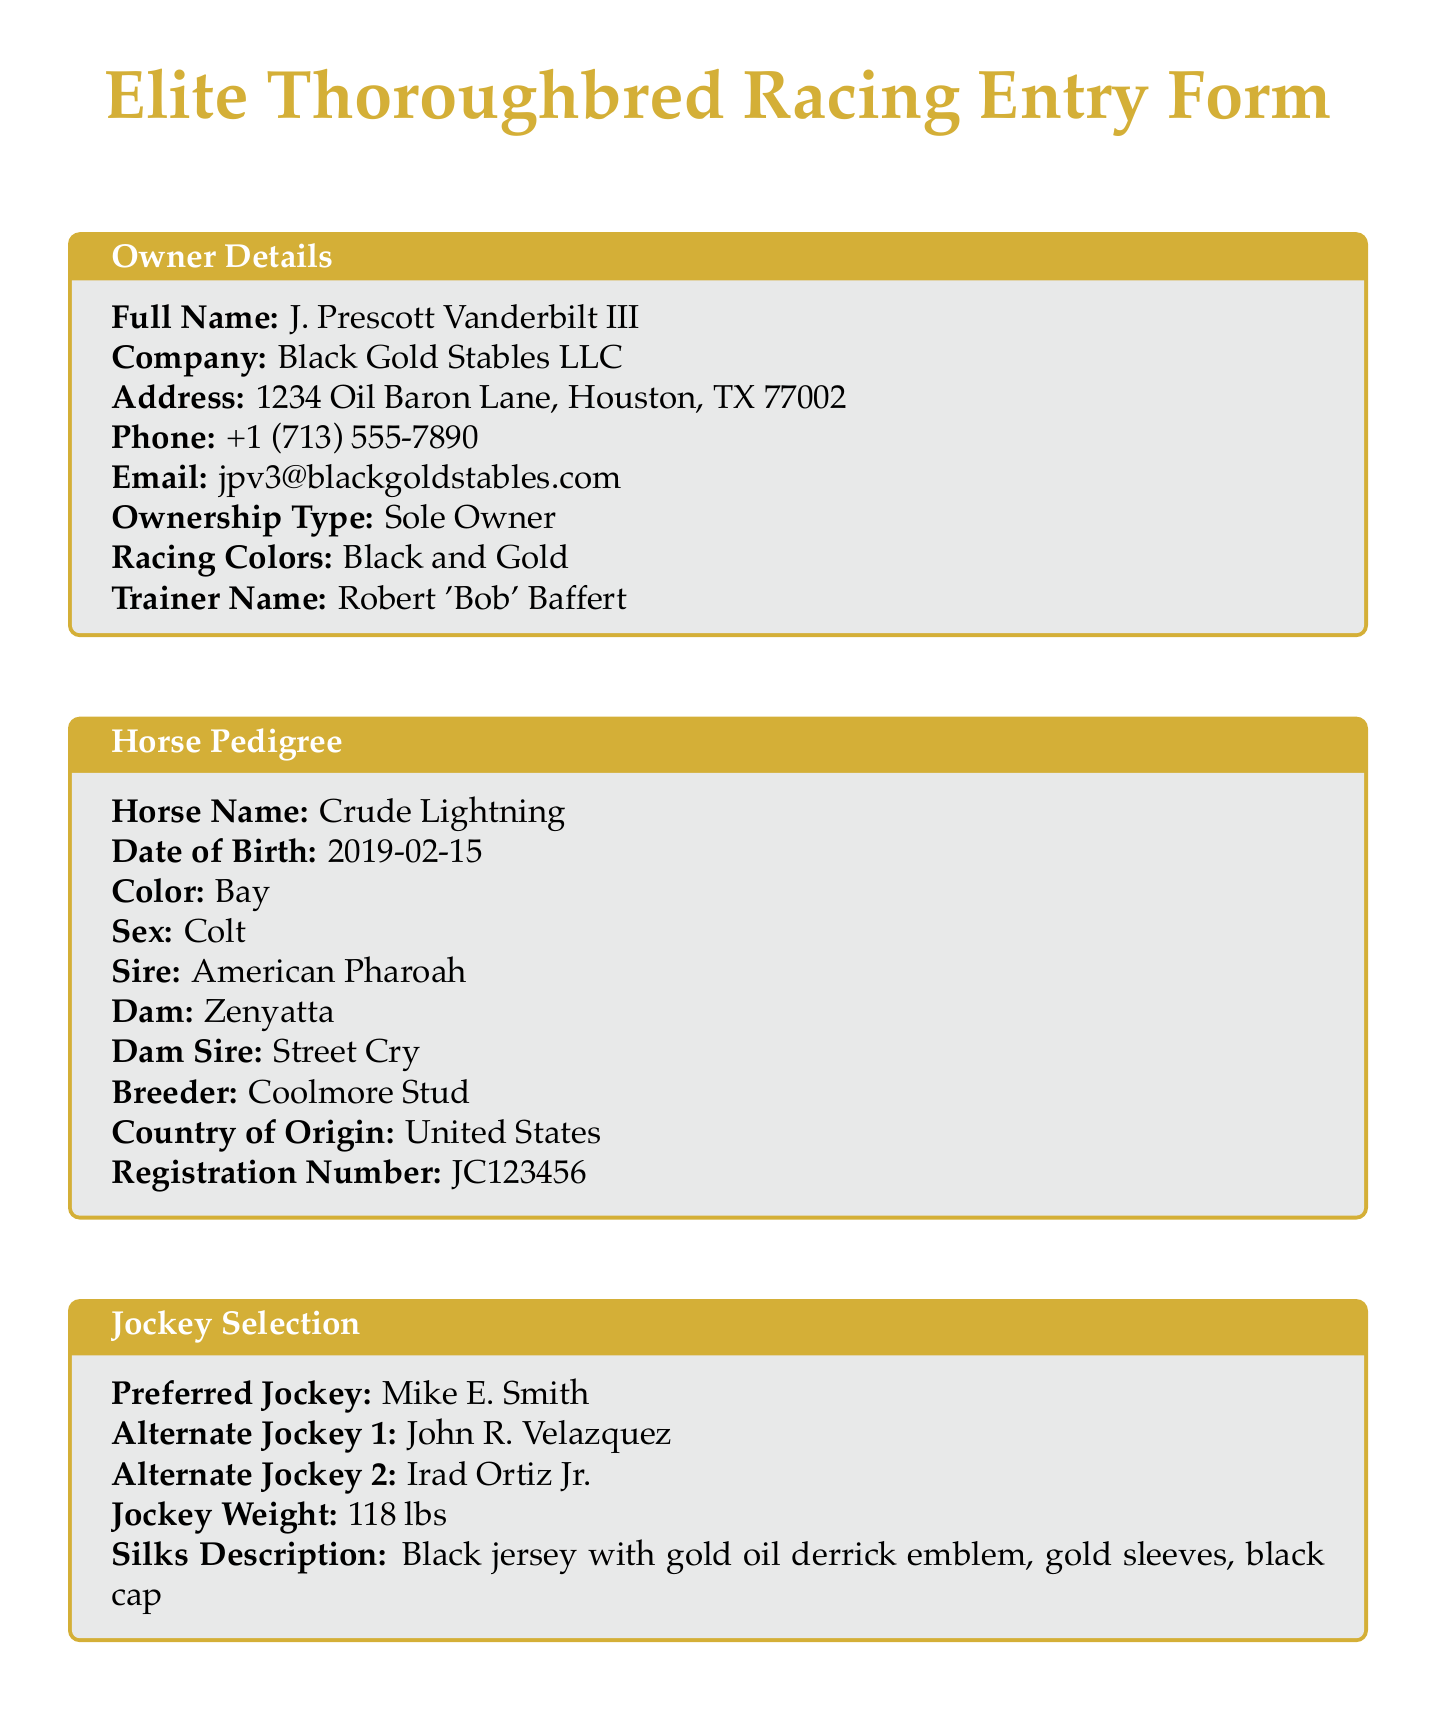what is the full name of the owner? The full name of the owner can be found in the Owner Details section of the document.
Answer: J. Prescott Vanderbilt III what is the horse's date of birth? The date of birth for the horse is listed in the Horse Pedigree section of the document.
Answer: 2019-02-15 who is the preferred jockey? The preferred jockey is mentioned in the Jockey Selection section of the document.
Answer: Mike E. Smith what is the race name? The name of the race is provided in the Race Details section of the document.
Answer: Kentucky Derby how many total starts does the horse have? The total number of starts for the horse can be found in the Horse Past Performance section of the document.
Answer: 6 what is the total purse for the race? The total purse for the race is specified in the Race Details section of the document.
Answer: $3,000,000 who is the veterinarian? The veterinarian's name is listed in the Veterinary Information section of the document.
Answer: Dr. Elizabeth Chambers what is the entry fee amount? The amount for the entry fee is stated in the Entry Fees section of the document.
Answer: $50,000 what are the racing colors? The racing colors can be found in the Owner Details section of the document.
Answer: Black and Gold 